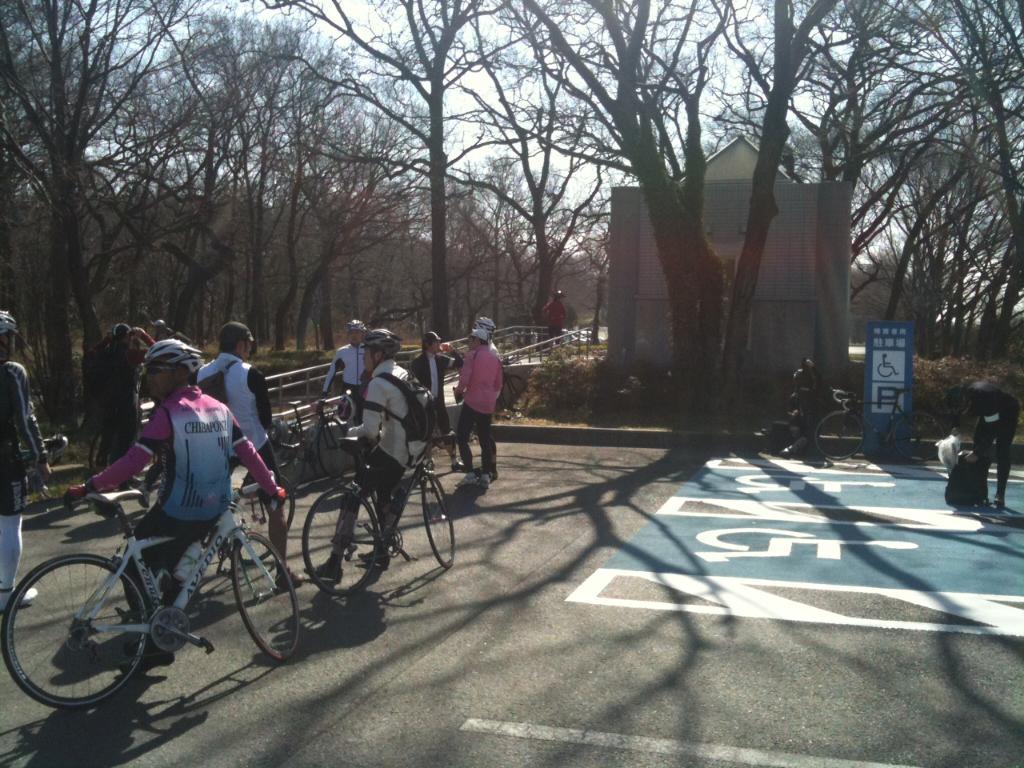Describe this image in one or two sentences. In this image on the right side there are some people who are sitting on cycles, and some of them holding cycles and some of them are standing and talking. At the bottom there is a road, on the right side there are some persons and cycles. And in the background there are some trees and one tent and there is a bridge. 